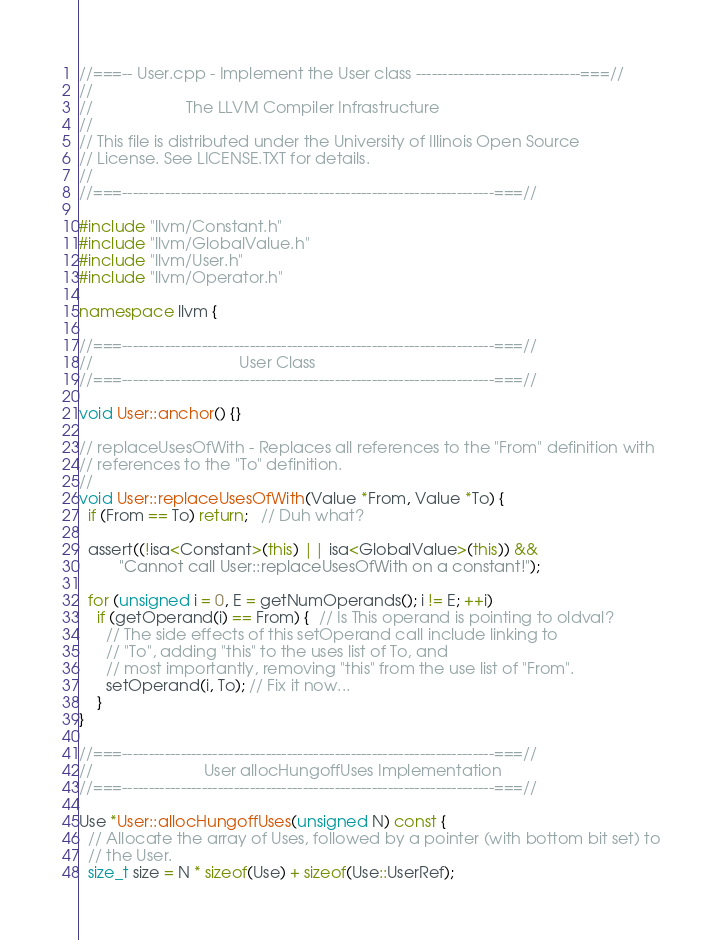Convert code to text. <code><loc_0><loc_0><loc_500><loc_500><_C++_>//===-- User.cpp - Implement the User class -------------------------------===//
//
//                     The LLVM Compiler Infrastructure
//
// This file is distributed under the University of Illinois Open Source
// License. See LICENSE.TXT for details.
//
//===----------------------------------------------------------------------===//

#include "llvm/Constant.h"
#include "llvm/GlobalValue.h"
#include "llvm/User.h"
#include "llvm/Operator.h"

namespace llvm {

//===----------------------------------------------------------------------===//
//                                 User Class
//===----------------------------------------------------------------------===//

void User::anchor() {}

// replaceUsesOfWith - Replaces all references to the "From" definition with
// references to the "To" definition.
//
void User::replaceUsesOfWith(Value *From, Value *To) {
  if (From == To) return;   // Duh what?

  assert((!isa<Constant>(this) || isa<GlobalValue>(this)) &&
         "Cannot call User::replaceUsesOfWith on a constant!");

  for (unsigned i = 0, E = getNumOperands(); i != E; ++i)
    if (getOperand(i) == From) {  // Is This operand is pointing to oldval?
      // The side effects of this setOperand call include linking to
      // "To", adding "this" to the uses list of To, and
      // most importantly, removing "this" from the use list of "From".
      setOperand(i, To); // Fix it now...
    }
}

//===----------------------------------------------------------------------===//
//                         User allocHungoffUses Implementation
//===----------------------------------------------------------------------===//

Use *User::allocHungoffUses(unsigned N) const {
  // Allocate the array of Uses, followed by a pointer (with bottom bit set) to
  // the User.
  size_t size = N * sizeof(Use) + sizeof(Use::UserRef);</code> 